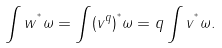<formula> <loc_0><loc_0><loc_500><loc_500>\int w ^ { ^ { * } } \omega = \int ( v ^ { q } ) ^ { ^ { * } } \omega = q \int v ^ { ^ { * } } \omega .</formula> 